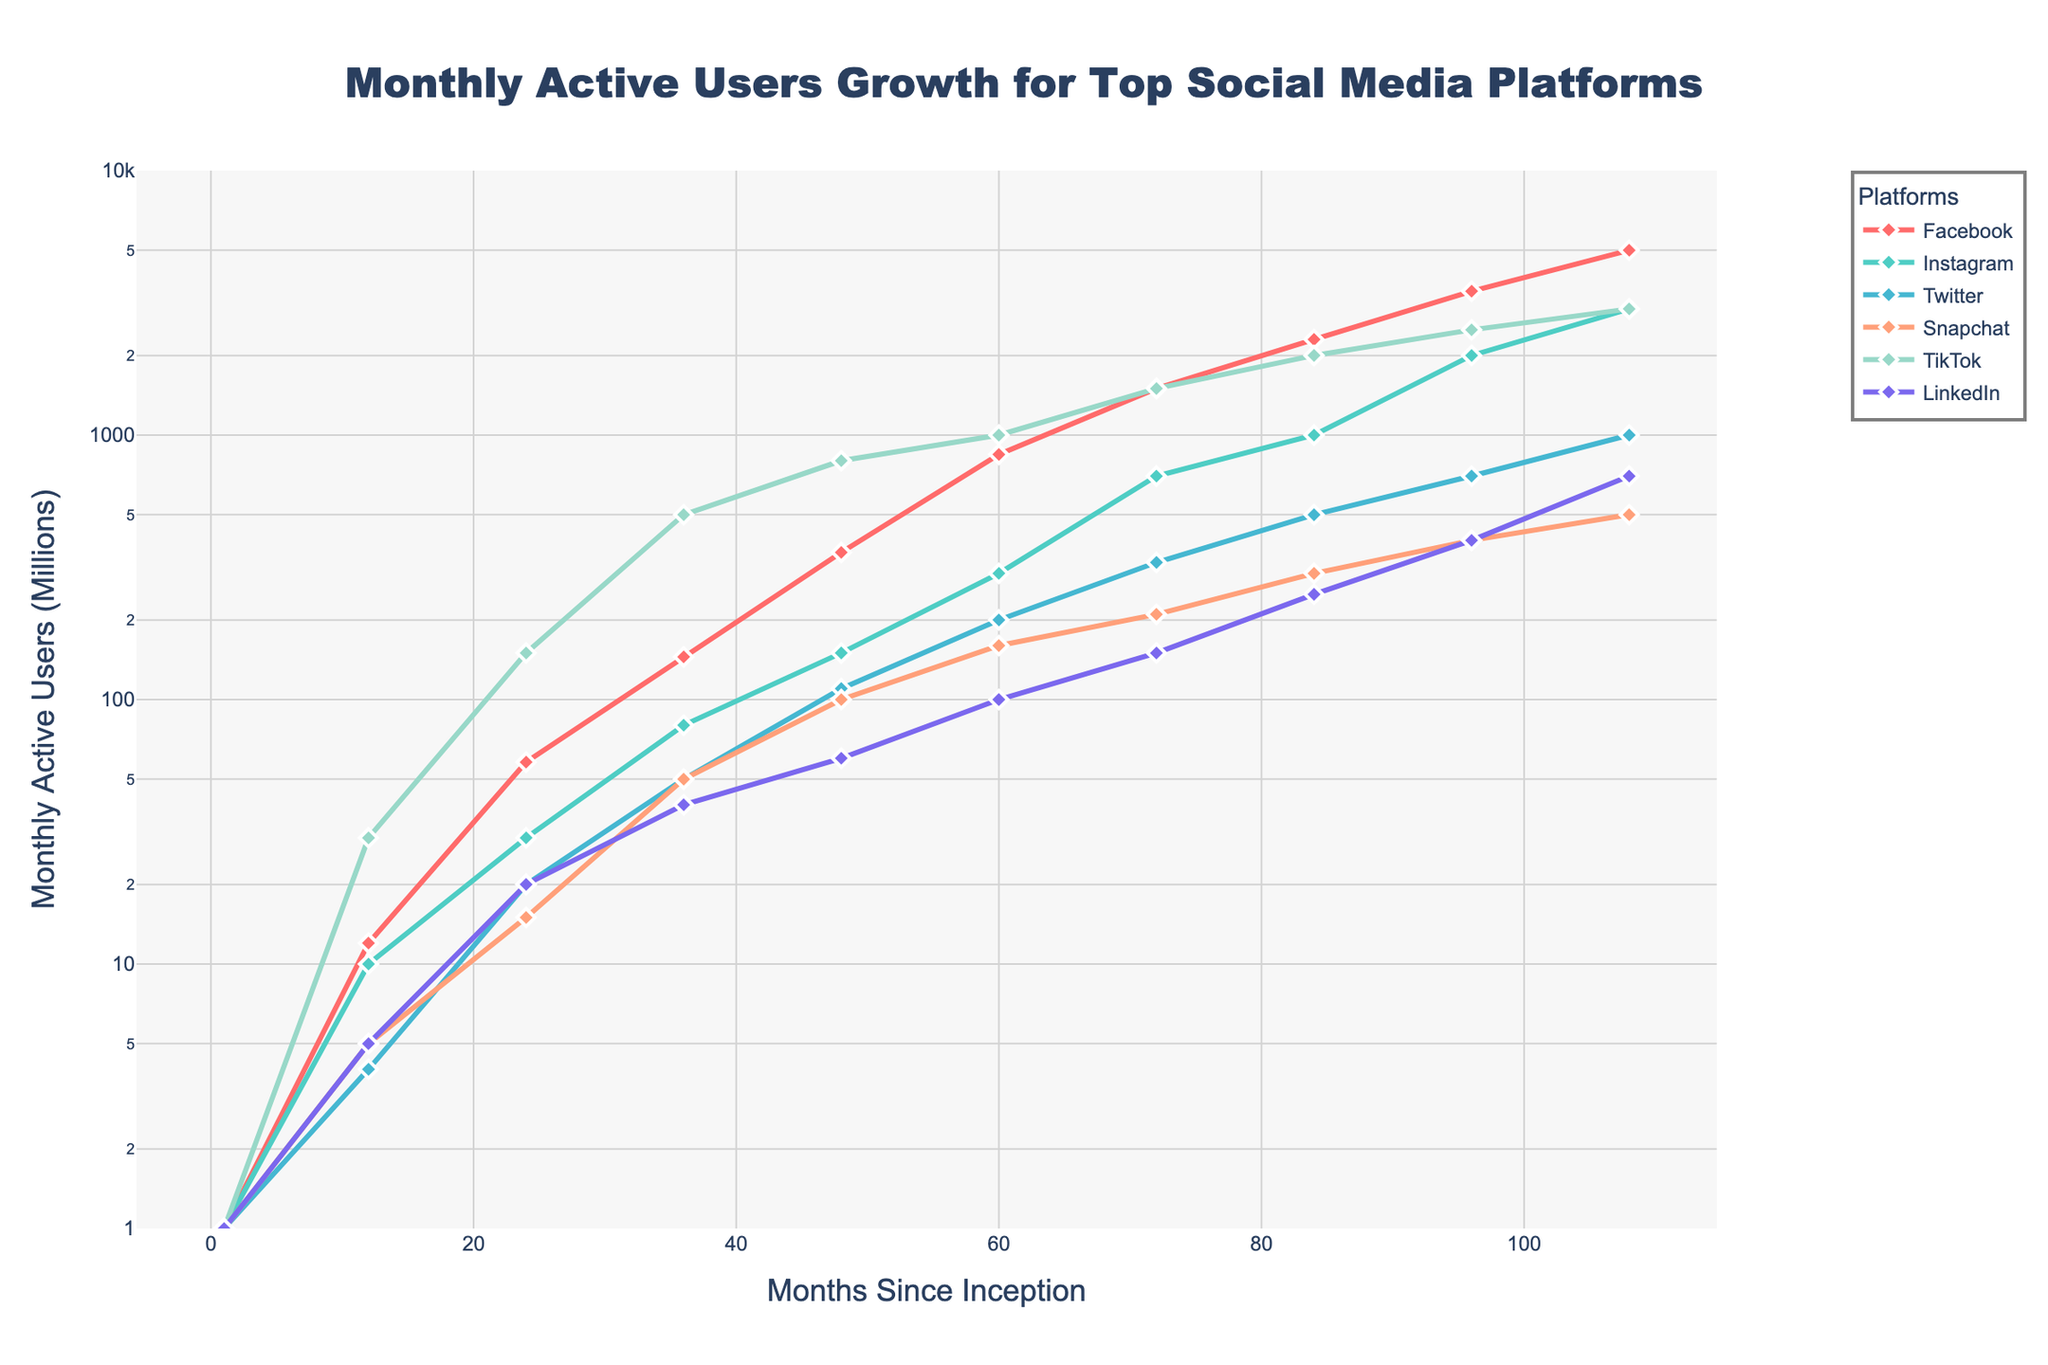Which platform has the highest monthly active users at 108 months since inception? At 108 months, the figure shows the user growth for all platforms. TikTok and Instagram both show 3000 million users, the highest amongst all platforms.
Answer: TikTok and Instagram What is the approximate rate of growth for Facebook between 12 and 24 months? To find the rate of growth, observe Facebook's user count at 12 months (12 million) and at 24 months (58 million). Calculate the difference and then divide by the time span (24-12 = 12 months). The rate of growth is (58 - 12) / 12 = 46/12 ≈ 3.83 million users per month.
Answer: 3.83 million users/month Which platform reached 1000 million monthly active users the fastest? Check when each platform recorded 1000 million users for the first time. TikTok reached 1000 million users at around 60 months, faster than any other platform.
Answer: TikTok Compare the user growth trajectories of Snapchat and LinkedIn. Which had a faster growth rate in the early months? For early months (1 to 48), compare the two lines for Snapchat and LinkedIn. Snapchat had a steeper slope indicating a faster growth rate, reaching around 100 million users by 48 months while LinkedIn was around 60 million users.
Answer: Snapchat How many platforms exceeded 2000 million monthly active users by 108 months since inception? At 108 months, visually inspect the lines to check which platforms crossed the 2000 million mark. Facebook, Instagram, and TikTok did.
Answer: Three platforms Which platform showed a significant spike in growth between months 24 and 36? Reviewing the plot, TikTok's line shows a dramatic increase between months 24 and 36, growing from 150 million to 500 million users.
Answer: TikTok What is the overall trend of Twitter's user growth over the 108 months? Observe Twitter's line from start to end: it starts from 1 million and climbs steadily to 1000 million users, indicating consistent growth.
Answer: Steady growth Between months 72 and 84, which platform experienced the highest user growth in absolute numbers? For each platform, calculate the increase in users between months 72 and 84. TikTok experienced the highest growth, rising from 1500 million to 2000 million, a 500 million increase.
Answer: TikTok Comparing Facebook and Instagram's growth, who had a steeper growth curve between 60 to 108 months? From 60 to 108 months, compare the slopes visually. Both start at 1000 million and rise significantly, but Facebook's curve is steeper and reaches 5000 million compared to Instagram's 3000 million.
Answer: Facebook 